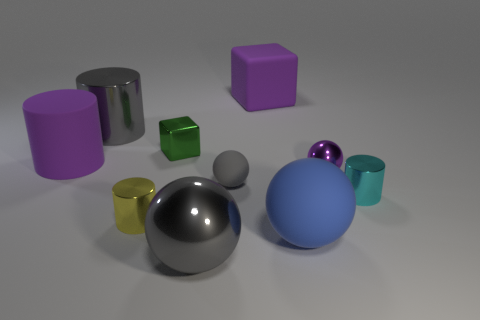There is a big gray object that is on the right side of the large gray thing that is behind the purple rubber object that is in front of the gray cylinder; what is its shape? sphere 